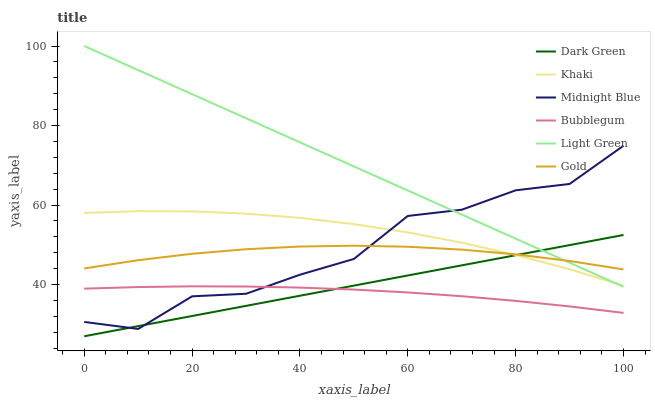Does Bubblegum have the minimum area under the curve?
Answer yes or no. Yes. Does Light Green have the maximum area under the curve?
Answer yes or no. Yes. Does Midnight Blue have the minimum area under the curve?
Answer yes or no. No. Does Midnight Blue have the maximum area under the curve?
Answer yes or no. No. Is Dark Green the smoothest?
Answer yes or no. Yes. Is Midnight Blue the roughest?
Answer yes or no. Yes. Is Gold the smoothest?
Answer yes or no. No. Is Gold the roughest?
Answer yes or no. No. Does Midnight Blue have the lowest value?
Answer yes or no. No. Does Midnight Blue have the highest value?
Answer yes or no. No. Is Bubblegum less than Khaki?
Answer yes or no. Yes. Is Khaki greater than Bubblegum?
Answer yes or no. Yes. Does Bubblegum intersect Khaki?
Answer yes or no. No. 